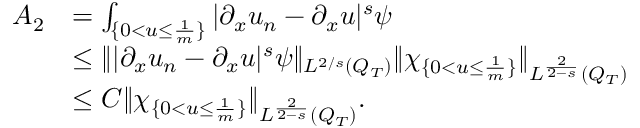Convert formula to latex. <formula><loc_0><loc_0><loc_500><loc_500>\begin{array} { r l } { A _ { 2 } } & { = \int _ { \{ 0 < u \leq \frac { 1 } { m } \} } | \partial _ { x } u _ { n } - \partial _ { x } u | ^ { s } \psi } \\ & { \leq \| | \partial _ { x } u _ { n } - \partial _ { x } u | ^ { s } \psi \| _ { L ^ { 2 / s } ( Q _ { T } ) } \| \chi _ { \{ 0 < u \leq \frac { 1 } { m } \} } \| _ { L ^ { \frac { 2 } { 2 - s } } ( Q _ { T } ) } } \\ & { \leq C \| \chi _ { \{ 0 < u \leq \frac { 1 } { m } \} } \| _ { L ^ { \frac { 2 } { 2 - s } } ( Q _ { T } ) } . } \end{array}</formula> 